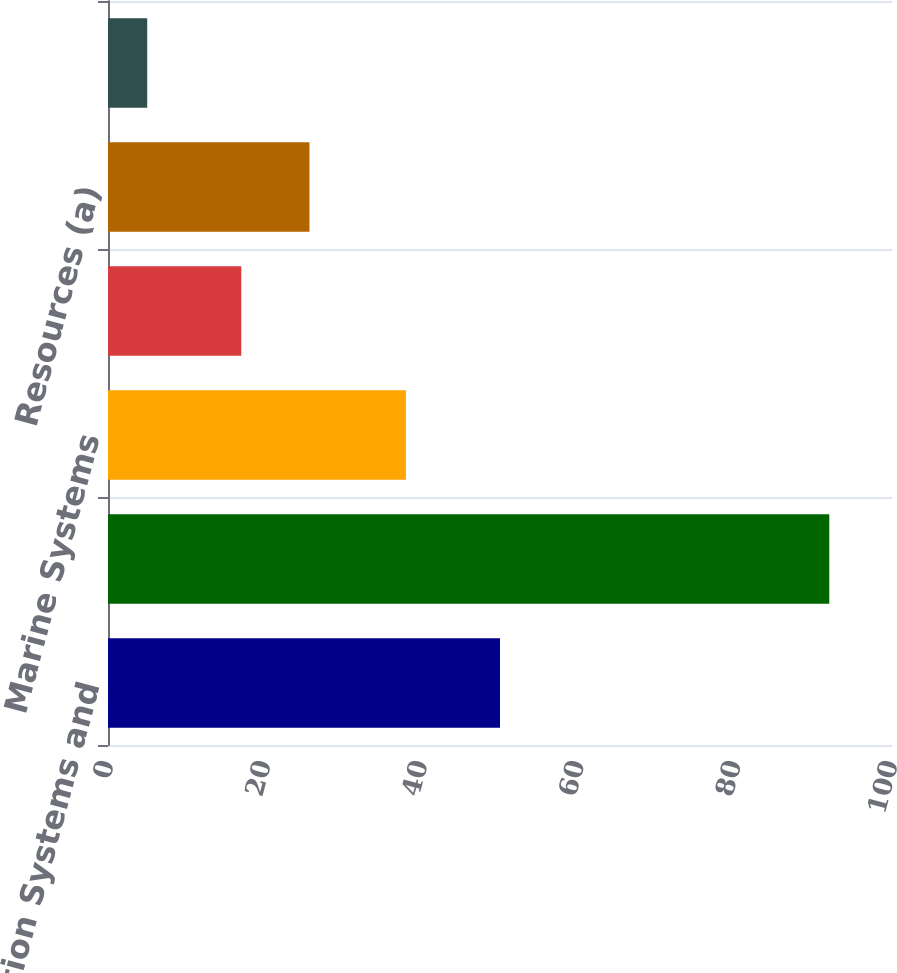<chart> <loc_0><loc_0><loc_500><loc_500><bar_chart><fcel>Information Systems and<fcel>Combat Systems<fcel>Marine Systems<fcel>Aerospace<fcel>Resources (a)<fcel>Corporate (b)<nl><fcel>50<fcel>92<fcel>38<fcel>17<fcel>25.7<fcel>5<nl></chart> 